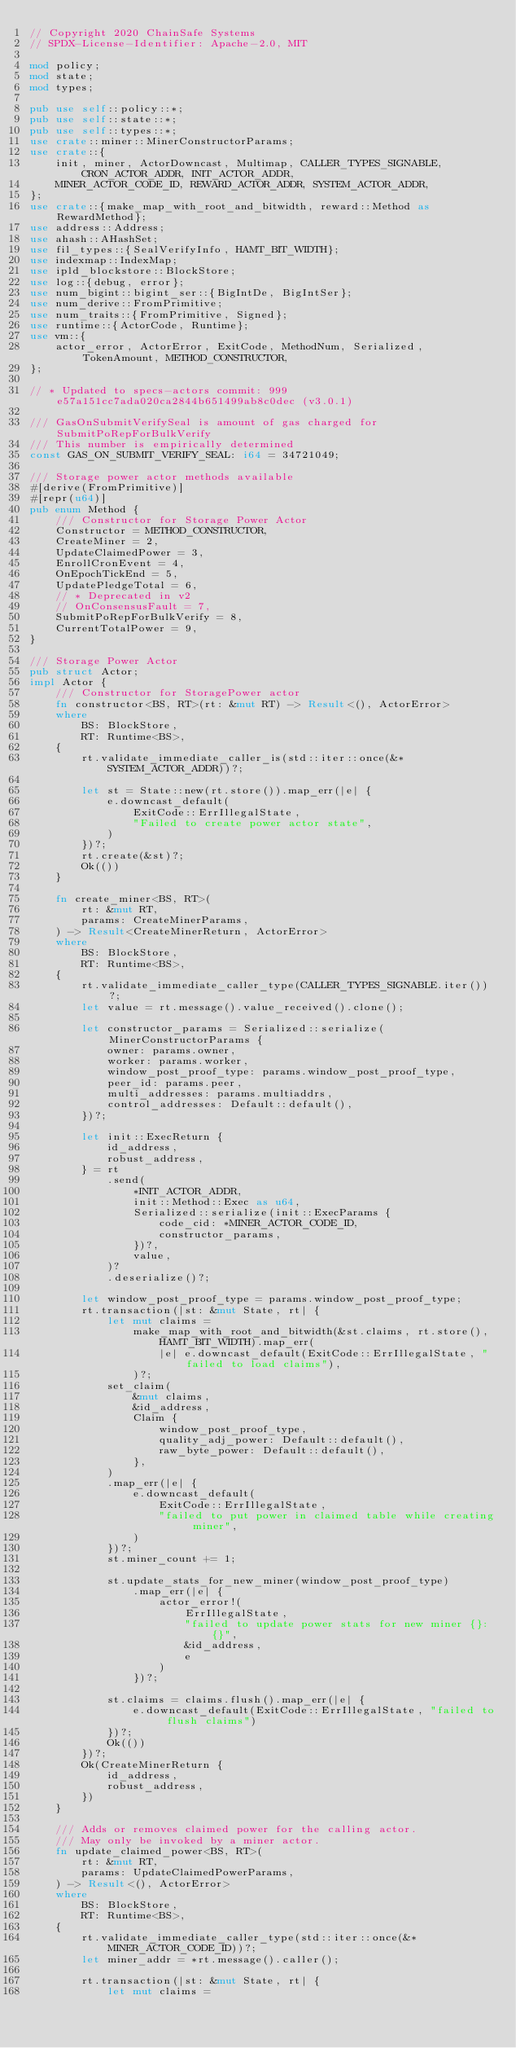Convert code to text. <code><loc_0><loc_0><loc_500><loc_500><_Rust_>// Copyright 2020 ChainSafe Systems
// SPDX-License-Identifier: Apache-2.0, MIT

mod policy;
mod state;
mod types;

pub use self::policy::*;
pub use self::state::*;
pub use self::types::*;
use crate::miner::MinerConstructorParams;
use crate::{
    init, miner, ActorDowncast, Multimap, CALLER_TYPES_SIGNABLE, CRON_ACTOR_ADDR, INIT_ACTOR_ADDR,
    MINER_ACTOR_CODE_ID, REWARD_ACTOR_ADDR, SYSTEM_ACTOR_ADDR,
};
use crate::{make_map_with_root_and_bitwidth, reward::Method as RewardMethod};
use address::Address;
use ahash::AHashSet;
use fil_types::{SealVerifyInfo, HAMT_BIT_WIDTH};
use indexmap::IndexMap;
use ipld_blockstore::BlockStore;
use log::{debug, error};
use num_bigint::bigint_ser::{BigIntDe, BigIntSer};
use num_derive::FromPrimitive;
use num_traits::{FromPrimitive, Signed};
use runtime::{ActorCode, Runtime};
use vm::{
    actor_error, ActorError, ExitCode, MethodNum, Serialized, TokenAmount, METHOD_CONSTRUCTOR,
};

// * Updated to specs-actors commit: 999e57a151cc7ada020ca2844b651499ab8c0dec (v3.0.1)

/// GasOnSubmitVerifySeal is amount of gas charged for SubmitPoRepForBulkVerify
/// This number is empirically determined
const GAS_ON_SUBMIT_VERIFY_SEAL: i64 = 34721049;

/// Storage power actor methods available
#[derive(FromPrimitive)]
#[repr(u64)]
pub enum Method {
    /// Constructor for Storage Power Actor
    Constructor = METHOD_CONSTRUCTOR,
    CreateMiner = 2,
    UpdateClaimedPower = 3,
    EnrollCronEvent = 4,
    OnEpochTickEnd = 5,
    UpdatePledgeTotal = 6,
    // * Deprecated in v2
    // OnConsensusFault = 7,
    SubmitPoRepForBulkVerify = 8,
    CurrentTotalPower = 9,
}

/// Storage Power Actor
pub struct Actor;
impl Actor {
    /// Constructor for StoragePower actor
    fn constructor<BS, RT>(rt: &mut RT) -> Result<(), ActorError>
    where
        BS: BlockStore,
        RT: Runtime<BS>,
    {
        rt.validate_immediate_caller_is(std::iter::once(&*SYSTEM_ACTOR_ADDR))?;

        let st = State::new(rt.store()).map_err(|e| {
            e.downcast_default(
                ExitCode::ErrIllegalState,
                "Failed to create power actor state",
            )
        })?;
        rt.create(&st)?;
        Ok(())
    }

    fn create_miner<BS, RT>(
        rt: &mut RT,
        params: CreateMinerParams,
    ) -> Result<CreateMinerReturn, ActorError>
    where
        BS: BlockStore,
        RT: Runtime<BS>,
    {
        rt.validate_immediate_caller_type(CALLER_TYPES_SIGNABLE.iter())?;
        let value = rt.message().value_received().clone();

        let constructor_params = Serialized::serialize(MinerConstructorParams {
            owner: params.owner,
            worker: params.worker,
            window_post_proof_type: params.window_post_proof_type,
            peer_id: params.peer,
            multi_addresses: params.multiaddrs,
            control_addresses: Default::default(),
        })?;

        let init::ExecReturn {
            id_address,
            robust_address,
        } = rt
            .send(
                *INIT_ACTOR_ADDR,
                init::Method::Exec as u64,
                Serialized::serialize(init::ExecParams {
                    code_cid: *MINER_ACTOR_CODE_ID,
                    constructor_params,
                })?,
                value,
            )?
            .deserialize()?;

        let window_post_proof_type = params.window_post_proof_type;
        rt.transaction(|st: &mut State, rt| {
            let mut claims =
                make_map_with_root_and_bitwidth(&st.claims, rt.store(), HAMT_BIT_WIDTH).map_err(
                    |e| e.downcast_default(ExitCode::ErrIllegalState, "failed to load claims"),
                )?;
            set_claim(
                &mut claims,
                &id_address,
                Claim {
                    window_post_proof_type,
                    quality_adj_power: Default::default(),
                    raw_byte_power: Default::default(),
                },
            )
            .map_err(|e| {
                e.downcast_default(
                    ExitCode::ErrIllegalState,
                    "failed to put power in claimed table while creating miner",
                )
            })?;
            st.miner_count += 1;

            st.update_stats_for_new_miner(window_post_proof_type)
                .map_err(|e| {
                    actor_error!(
                        ErrIllegalState,
                        "failed to update power stats for new miner {}: {}",
                        &id_address,
                        e
                    )
                })?;

            st.claims = claims.flush().map_err(|e| {
                e.downcast_default(ExitCode::ErrIllegalState, "failed to flush claims")
            })?;
            Ok(())
        })?;
        Ok(CreateMinerReturn {
            id_address,
            robust_address,
        })
    }

    /// Adds or removes claimed power for the calling actor.
    /// May only be invoked by a miner actor.
    fn update_claimed_power<BS, RT>(
        rt: &mut RT,
        params: UpdateClaimedPowerParams,
    ) -> Result<(), ActorError>
    where
        BS: BlockStore,
        RT: Runtime<BS>,
    {
        rt.validate_immediate_caller_type(std::iter::once(&*MINER_ACTOR_CODE_ID))?;
        let miner_addr = *rt.message().caller();

        rt.transaction(|st: &mut State, rt| {
            let mut claims =</code> 